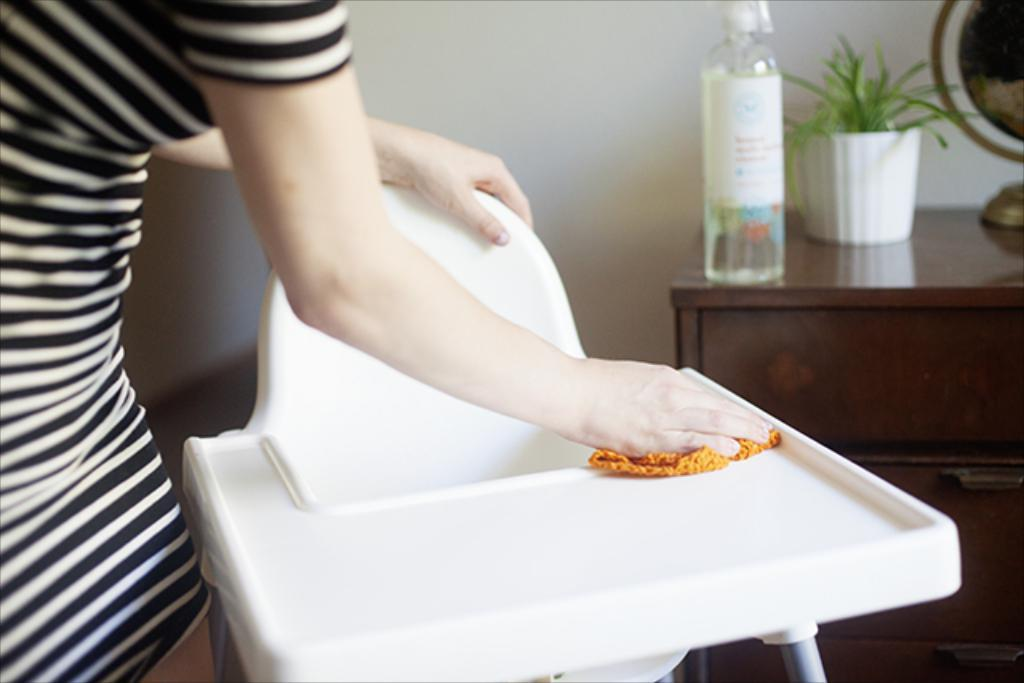Who is the main subject in the image? There is a lady in the image. What is the lady wearing? The lady is wearing a black and white dress. What is the lady doing in the image? The lady is cleaning a table. What can be seen to the right side of the image? There is a cupboard to the right side of the image. What items are on the cupboard? There is a bottle, a pot, and a globe on the cupboard. Can you see any ants crawling on the grass in the image? There is no grass present in the image, and therefore no ants can be seen. 